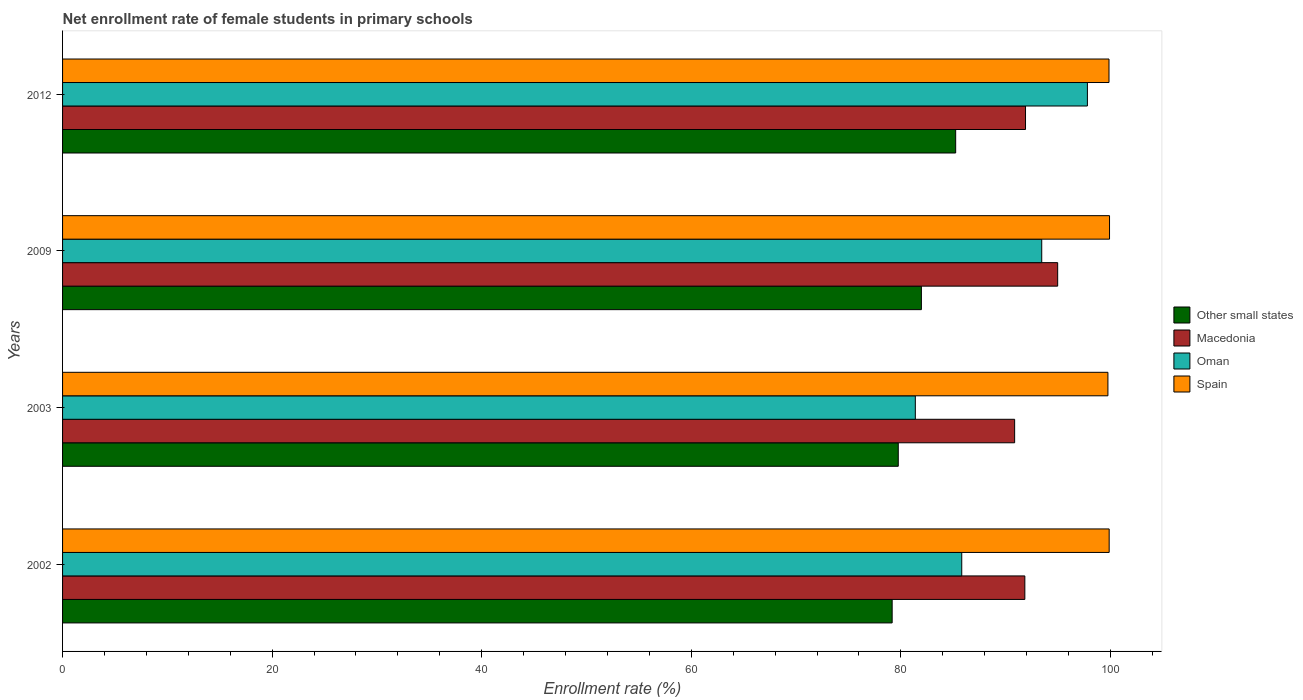How many different coloured bars are there?
Make the answer very short. 4. How many groups of bars are there?
Your answer should be compact. 4. Are the number of bars per tick equal to the number of legend labels?
Give a very brief answer. Yes. How many bars are there on the 3rd tick from the top?
Offer a terse response. 4. In how many cases, is the number of bars for a given year not equal to the number of legend labels?
Give a very brief answer. 0. What is the net enrollment rate of female students in primary schools in Other small states in 2012?
Your answer should be very brief. 85.23. Across all years, what is the maximum net enrollment rate of female students in primary schools in Spain?
Your answer should be compact. 99.91. Across all years, what is the minimum net enrollment rate of female students in primary schools in Macedonia?
Provide a succinct answer. 90.86. In which year was the net enrollment rate of female students in primary schools in Oman maximum?
Provide a short and direct response. 2012. In which year was the net enrollment rate of female students in primary schools in Spain minimum?
Your answer should be very brief. 2003. What is the total net enrollment rate of female students in primary schools in Macedonia in the graph?
Your answer should be compact. 369.55. What is the difference between the net enrollment rate of female students in primary schools in Macedonia in 2003 and that in 2012?
Ensure brevity in your answer.  -1.04. What is the difference between the net enrollment rate of female students in primary schools in Macedonia in 2003 and the net enrollment rate of female students in primary schools in Oman in 2012?
Ensure brevity in your answer.  -6.94. What is the average net enrollment rate of female students in primary schools in Macedonia per year?
Give a very brief answer. 92.39. In the year 2003, what is the difference between the net enrollment rate of female students in primary schools in Macedonia and net enrollment rate of female students in primary schools in Other small states?
Your answer should be compact. 11.11. What is the ratio of the net enrollment rate of female students in primary schools in Macedonia in 2009 to that in 2012?
Make the answer very short. 1.03. Is the net enrollment rate of female students in primary schools in Macedonia in 2002 less than that in 2003?
Your answer should be compact. No. What is the difference between the highest and the second highest net enrollment rate of female students in primary schools in Oman?
Offer a very short reply. 4.36. What is the difference between the highest and the lowest net enrollment rate of female students in primary schools in Spain?
Ensure brevity in your answer.  0.15. Is the sum of the net enrollment rate of female students in primary schools in Oman in 2003 and 2012 greater than the maximum net enrollment rate of female students in primary schools in Other small states across all years?
Provide a short and direct response. Yes. What does the 1st bar from the top in 2009 represents?
Keep it short and to the point. Spain. What does the 1st bar from the bottom in 2009 represents?
Offer a terse response. Other small states. Is it the case that in every year, the sum of the net enrollment rate of female students in primary schools in Spain and net enrollment rate of female students in primary schools in Oman is greater than the net enrollment rate of female students in primary schools in Other small states?
Your answer should be compact. Yes. How many bars are there?
Make the answer very short. 16. Are all the bars in the graph horizontal?
Make the answer very short. Yes. What is the difference between two consecutive major ticks on the X-axis?
Offer a very short reply. 20. Are the values on the major ticks of X-axis written in scientific E-notation?
Give a very brief answer. No. Does the graph contain any zero values?
Offer a terse response. No. Does the graph contain grids?
Provide a succinct answer. No. How are the legend labels stacked?
Make the answer very short. Vertical. What is the title of the graph?
Give a very brief answer. Net enrollment rate of female students in primary schools. What is the label or title of the X-axis?
Offer a terse response. Enrollment rate (%). What is the Enrollment rate (%) in Other small states in 2002?
Offer a terse response. 79.17. What is the Enrollment rate (%) of Macedonia in 2002?
Offer a very short reply. 91.83. What is the Enrollment rate (%) in Oman in 2002?
Provide a short and direct response. 85.81. What is the Enrollment rate (%) in Spain in 2002?
Provide a succinct answer. 99.88. What is the Enrollment rate (%) of Other small states in 2003?
Offer a terse response. 79.75. What is the Enrollment rate (%) in Macedonia in 2003?
Keep it short and to the point. 90.86. What is the Enrollment rate (%) in Oman in 2003?
Ensure brevity in your answer.  81.38. What is the Enrollment rate (%) of Spain in 2003?
Give a very brief answer. 99.76. What is the Enrollment rate (%) of Other small states in 2009?
Keep it short and to the point. 81.96. What is the Enrollment rate (%) in Macedonia in 2009?
Your response must be concise. 94.97. What is the Enrollment rate (%) of Oman in 2009?
Offer a very short reply. 93.44. What is the Enrollment rate (%) of Spain in 2009?
Your answer should be compact. 99.91. What is the Enrollment rate (%) of Other small states in 2012?
Keep it short and to the point. 85.23. What is the Enrollment rate (%) in Macedonia in 2012?
Offer a very short reply. 91.9. What is the Enrollment rate (%) in Oman in 2012?
Give a very brief answer. 97.8. What is the Enrollment rate (%) of Spain in 2012?
Make the answer very short. 99.86. Across all years, what is the maximum Enrollment rate (%) in Other small states?
Provide a succinct answer. 85.23. Across all years, what is the maximum Enrollment rate (%) of Macedonia?
Keep it short and to the point. 94.97. Across all years, what is the maximum Enrollment rate (%) in Oman?
Ensure brevity in your answer.  97.8. Across all years, what is the maximum Enrollment rate (%) of Spain?
Ensure brevity in your answer.  99.91. Across all years, what is the minimum Enrollment rate (%) in Other small states?
Ensure brevity in your answer.  79.17. Across all years, what is the minimum Enrollment rate (%) of Macedonia?
Make the answer very short. 90.86. Across all years, what is the minimum Enrollment rate (%) of Oman?
Ensure brevity in your answer.  81.38. Across all years, what is the minimum Enrollment rate (%) in Spain?
Your answer should be very brief. 99.76. What is the total Enrollment rate (%) in Other small states in the graph?
Offer a terse response. 326.11. What is the total Enrollment rate (%) in Macedonia in the graph?
Your response must be concise. 369.55. What is the total Enrollment rate (%) of Oman in the graph?
Keep it short and to the point. 358.44. What is the total Enrollment rate (%) of Spain in the graph?
Provide a short and direct response. 399.42. What is the difference between the Enrollment rate (%) in Other small states in 2002 and that in 2003?
Provide a succinct answer. -0.58. What is the difference between the Enrollment rate (%) of Macedonia in 2002 and that in 2003?
Provide a succinct answer. 0.97. What is the difference between the Enrollment rate (%) of Oman in 2002 and that in 2003?
Keep it short and to the point. 4.43. What is the difference between the Enrollment rate (%) of Spain in 2002 and that in 2003?
Your answer should be compact. 0.12. What is the difference between the Enrollment rate (%) of Other small states in 2002 and that in 2009?
Your answer should be very brief. -2.79. What is the difference between the Enrollment rate (%) in Macedonia in 2002 and that in 2009?
Ensure brevity in your answer.  -3.13. What is the difference between the Enrollment rate (%) in Oman in 2002 and that in 2009?
Make the answer very short. -7.63. What is the difference between the Enrollment rate (%) of Spain in 2002 and that in 2009?
Make the answer very short. -0.03. What is the difference between the Enrollment rate (%) of Other small states in 2002 and that in 2012?
Give a very brief answer. -6.06. What is the difference between the Enrollment rate (%) of Macedonia in 2002 and that in 2012?
Make the answer very short. -0.06. What is the difference between the Enrollment rate (%) of Oman in 2002 and that in 2012?
Make the answer very short. -11.99. What is the difference between the Enrollment rate (%) of Spain in 2002 and that in 2012?
Your answer should be very brief. 0.02. What is the difference between the Enrollment rate (%) of Other small states in 2003 and that in 2009?
Provide a succinct answer. -2.21. What is the difference between the Enrollment rate (%) in Macedonia in 2003 and that in 2009?
Your answer should be compact. -4.11. What is the difference between the Enrollment rate (%) of Oman in 2003 and that in 2009?
Provide a succinct answer. -12.06. What is the difference between the Enrollment rate (%) in Spain in 2003 and that in 2009?
Offer a terse response. -0.15. What is the difference between the Enrollment rate (%) in Other small states in 2003 and that in 2012?
Offer a terse response. -5.48. What is the difference between the Enrollment rate (%) of Macedonia in 2003 and that in 2012?
Give a very brief answer. -1.04. What is the difference between the Enrollment rate (%) of Oman in 2003 and that in 2012?
Your answer should be very brief. -16.42. What is the difference between the Enrollment rate (%) in Spain in 2003 and that in 2012?
Give a very brief answer. -0.1. What is the difference between the Enrollment rate (%) in Other small states in 2009 and that in 2012?
Provide a short and direct response. -3.27. What is the difference between the Enrollment rate (%) in Macedonia in 2009 and that in 2012?
Offer a terse response. 3.07. What is the difference between the Enrollment rate (%) of Oman in 2009 and that in 2012?
Ensure brevity in your answer.  -4.36. What is the difference between the Enrollment rate (%) in Spain in 2009 and that in 2012?
Offer a very short reply. 0.05. What is the difference between the Enrollment rate (%) in Other small states in 2002 and the Enrollment rate (%) in Macedonia in 2003?
Provide a short and direct response. -11.69. What is the difference between the Enrollment rate (%) of Other small states in 2002 and the Enrollment rate (%) of Oman in 2003?
Offer a terse response. -2.21. What is the difference between the Enrollment rate (%) of Other small states in 2002 and the Enrollment rate (%) of Spain in 2003?
Give a very brief answer. -20.59. What is the difference between the Enrollment rate (%) of Macedonia in 2002 and the Enrollment rate (%) of Oman in 2003?
Give a very brief answer. 10.45. What is the difference between the Enrollment rate (%) in Macedonia in 2002 and the Enrollment rate (%) in Spain in 2003?
Offer a terse response. -7.93. What is the difference between the Enrollment rate (%) of Oman in 2002 and the Enrollment rate (%) of Spain in 2003?
Keep it short and to the point. -13.95. What is the difference between the Enrollment rate (%) of Other small states in 2002 and the Enrollment rate (%) of Macedonia in 2009?
Ensure brevity in your answer.  -15.8. What is the difference between the Enrollment rate (%) of Other small states in 2002 and the Enrollment rate (%) of Oman in 2009?
Provide a short and direct response. -14.27. What is the difference between the Enrollment rate (%) of Other small states in 2002 and the Enrollment rate (%) of Spain in 2009?
Give a very brief answer. -20.74. What is the difference between the Enrollment rate (%) of Macedonia in 2002 and the Enrollment rate (%) of Oman in 2009?
Ensure brevity in your answer.  -1.61. What is the difference between the Enrollment rate (%) of Macedonia in 2002 and the Enrollment rate (%) of Spain in 2009?
Offer a very short reply. -8.08. What is the difference between the Enrollment rate (%) of Oman in 2002 and the Enrollment rate (%) of Spain in 2009?
Your answer should be very brief. -14.1. What is the difference between the Enrollment rate (%) in Other small states in 2002 and the Enrollment rate (%) in Macedonia in 2012?
Your answer should be compact. -12.73. What is the difference between the Enrollment rate (%) of Other small states in 2002 and the Enrollment rate (%) of Oman in 2012?
Make the answer very short. -18.63. What is the difference between the Enrollment rate (%) in Other small states in 2002 and the Enrollment rate (%) in Spain in 2012?
Offer a very short reply. -20.69. What is the difference between the Enrollment rate (%) of Macedonia in 2002 and the Enrollment rate (%) of Oman in 2012?
Ensure brevity in your answer.  -5.97. What is the difference between the Enrollment rate (%) in Macedonia in 2002 and the Enrollment rate (%) in Spain in 2012?
Your answer should be very brief. -8.03. What is the difference between the Enrollment rate (%) in Oman in 2002 and the Enrollment rate (%) in Spain in 2012?
Give a very brief answer. -14.05. What is the difference between the Enrollment rate (%) in Other small states in 2003 and the Enrollment rate (%) in Macedonia in 2009?
Your answer should be compact. -15.21. What is the difference between the Enrollment rate (%) of Other small states in 2003 and the Enrollment rate (%) of Oman in 2009?
Give a very brief answer. -13.69. What is the difference between the Enrollment rate (%) in Other small states in 2003 and the Enrollment rate (%) in Spain in 2009?
Provide a succinct answer. -20.16. What is the difference between the Enrollment rate (%) in Macedonia in 2003 and the Enrollment rate (%) in Oman in 2009?
Ensure brevity in your answer.  -2.59. What is the difference between the Enrollment rate (%) in Macedonia in 2003 and the Enrollment rate (%) in Spain in 2009?
Provide a short and direct response. -9.06. What is the difference between the Enrollment rate (%) of Oman in 2003 and the Enrollment rate (%) of Spain in 2009?
Provide a short and direct response. -18.53. What is the difference between the Enrollment rate (%) of Other small states in 2003 and the Enrollment rate (%) of Macedonia in 2012?
Keep it short and to the point. -12.14. What is the difference between the Enrollment rate (%) in Other small states in 2003 and the Enrollment rate (%) in Oman in 2012?
Offer a very short reply. -18.05. What is the difference between the Enrollment rate (%) in Other small states in 2003 and the Enrollment rate (%) in Spain in 2012?
Ensure brevity in your answer.  -20.11. What is the difference between the Enrollment rate (%) of Macedonia in 2003 and the Enrollment rate (%) of Oman in 2012?
Your answer should be very brief. -6.94. What is the difference between the Enrollment rate (%) in Macedonia in 2003 and the Enrollment rate (%) in Spain in 2012?
Provide a succinct answer. -9. What is the difference between the Enrollment rate (%) in Oman in 2003 and the Enrollment rate (%) in Spain in 2012?
Offer a very short reply. -18.48. What is the difference between the Enrollment rate (%) of Other small states in 2009 and the Enrollment rate (%) of Macedonia in 2012?
Offer a terse response. -9.94. What is the difference between the Enrollment rate (%) of Other small states in 2009 and the Enrollment rate (%) of Oman in 2012?
Offer a very short reply. -15.84. What is the difference between the Enrollment rate (%) in Other small states in 2009 and the Enrollment rate (%) in Spain in 2012?
Make the answer very short. -17.9. What is the difference between the Enrollment rate (%) of Macedonia in 2009 and the Enrollment rate (%) of Oman in 2012?
Offer a very short reply. -2.84. What is the difference between the Enrollment rate (%) in Macedonia in 2009 and the Enrollment rate (%) in Spain in 2012?
Offer a very short reply. -4.9. What is the difference between the Enrollment rate (%) of Oman in 2009 and the Enrollment rate (%) of Spain in 2012?
Give a very brief answer. -6.42. What is the average Enrollment rate (%) in Other small states per year?
Provide a succinct answer. 81.53. What is the average Enrollment rate (%) in Macedonia per year?
Make the answer very short. 92.39. What is the average Enrollment rate (%) of Oman per year?
Provide a short and direct response. 89.61. What is the average Enrollment rate (%) in Spain per year?
Ensure brevity in your answer.  99.85. In the year 2002, what is the difference between the Enrollment rate (%) in Other small states and Enrollment rate (%) in Macedonia?
Provide a succinct answer. -12.66. In the year 2002, what is the difference between the Enrollment rate (%) in Other small states and Enrollment rate (%) in Oman?
Ensure brevity in your answer.  -6.64. In the year 2002, what is the difference between the Enrollment rate (%) in Other small states and Enrollment rate (%) in Spain?
Your answer should be very brief. -20.71. In the year 2002, what is the difference between the Enrollment rate (%) of Macedonia and Enrollment rate (%) of Oman?
Your answer should be compact. 6.02. In the year 2002, what is the difference between the Enrollment rate (%) in Macedonia and Enrollment rate (%) in Spain?
Provide a succinct answer. -8.05. In the year 2002, what is the difference between the Enrollment rate (%) of Oman and Enrollment rate (%) of Spain?
Make the answer very short. -14.07. In the year 2003, what is the difference between the Enrollment rate (%) of Other small states and Enrollment rate (%) of Macedonia?
Ensure brevity in your answer.  -11.11. In the year 2003, what is the difference between the Enrollment rate (%) in Other small states and Enrollment rate (%) in Oman?
Make the answer very short. -1.63. In the year 2003, what is the difference between the Enrollment rate (%) of Other small states and Enrollment rate (%) of Spain?
Give a very brief answer. -20.01. In the year 2003, what is the difference between the Enrollment rate (%) of Macedonia and Enrollment rate (%) of Oman?
Your response must be concise. 9.48. In the year 2003, what is the difference between the Enrollment rate (%) of Macedonia and Enrollment rate (%) of Spain?
Make the answer very short. -8.9. In the year 2003, what is the difference between the Enrollment rate (%) in Oman and Enrollment rate (%) in Spain?
Your answer should be compact. -18.38. In the year 2009, what is the difference between the Enrollment rate (%) of Other small states and Enrollment rate (%) of Macedonia?
Make the answer very short. -13.01. In the year 2009, what is the difference between the Enrollment rate (%) in Other small states and Enrollment rate (%) in Oman?
Give a very brief answer. -11.48. In the year 2009, what is the difference between the Enrollment rate (%) in Other small states and Enrollment rate (%) in Spain?
Give a very brief answer. -17.95. In the year 2009, what is the difference between the Enrollment rate (%) in Macedonia and Enrollment rate (%) in Oman?
Provide a succinct answer. 1.52. In the year 2009, what is the difference between the Enrollment rate (%) in Macedonia and Enrollment rate (%) in Spain?
Offer a very short reply. -4.95. In the year 2009, what is the difference between the Enrollment rate (%) in Oman and Enrollment rate (%) in Spain?
Your answer should be very brief. -6.47. In the year 2012, what is the difference between the Enrollment rate (%) of Other small states and Enrollment rate (%) of Macedonia?
Make the answer very short. -6.67. In the year 2012, what is the difference between the Enrollment rate (%) in Other small states and Enrollment rate (%) in Oman?
Give a very brief answer. -12.57. In the year 2012, what is the difference between the Enrollment rate (%) of Other small states and Enrollment rate (%) of Spain?
Offer a terse response. -14.63. In the year 2012, what is the difference between the Enrollment rate (%) in Macedonia and Enrollment rate (%) in Oman?
Offer a terse response. -5.91. In the year 2012, what is the difference between the Enrollment rate (%) in Macedonia and Enrollment rate (%) in Spain?
Give a very brief answer. -7.97. In the year 2012, what is the difference between the Enrollment rate (%) in Oman and Enrollment rate (%) in Spain?
Your answer should be compact. -2.06. What is the ratio of the Enrollment rate (%) in Other small states in 2002 to that in 2003?
Your answer should be very brief. 0.99. What is the ratio of the Enrollment rate (%) of Macedonia in 2002 to that in 2003?
Make the answer very short. 1.01. What is the ratio of the Enrollment rate (%) in Oman in 2002 to that in 2003?
Your response must be concise. 1.05. What is the ratio of the Enrollment rate (%) in Oman in 2002 to that in 2009?
Keep it short and to the point. 0.92. What is the ratio of the Enrollment rate (%) in Other small states in 2002 to that in 2012?
Offer a terse response. 0.93. What is the ratio of the Enrollment rate (%) in Macedonia in 2002 to that in 2012?
Ensure brevity in your answer.  1. What is the ratio of the Enrollment rate (%) of Oman in 2002 to that in 2012?
Ensure brevity in your answer.  0.88. What is the ratio of the Enrollment rate (%) in Other small states in 2003 to that in 2009?
Your answer should be very brief. 0.97. What is the ratio of the Enrollment rate (%) in Macedonia in 2003 to that in 2009?
Make the answer very short. 0.96. What is the ratio of the Enrollment rate (%) in Oman in 2003 to that in 2009?
Provide a short and direct response. 0.87. What is the ratio of the Enrollment rate (%) in Spain in 2003 to that in 2009?
Make the answer very short. 1. What is the ratio of the Enrollment rate (%) of Other small states in 2003 to that in 2012?
Your answer should be very brief. 0.94. What is the ratio of the Enrollment rate (%) of Macedonia in 2003 to that in 2012?
Provide a short and direct response. 0.99. What is the ratio of the Enrollment rate (%) in Oman in 2003 to that in 2012?
Your response must be concise. 0.83. What is the ratio of the Enrollment rate (%) in Other small states in 2009 to that in 2012?
Your answer should be very brief. 0.96. What is the ratio of the Enrollment rate (%) in Macedonia in 2009 to that in 2012?
Ensure brevity in your answer.  1.03. What is the ratio of the Enrollment rate (%) of Oman in 2009 to that in 2012?
Ensure brevity in your answer.  0.96. What is the ratio of the Enrollment rate (%) in Spain in 2009 to that in 2012?
Your answer should be very brief. 1. What is the difference between the highest and the second highest Enrollment rate (%) in Other small states?
Your answer should be very brief. 3.27. What is the difference between the highest and the second highest Enrollment rate (%) of Macedonia?
Your answer should be very brief. 3.07. What is the difference between the highest and the second highest Enrollment rate (%) in Oman?
Provide a short and direct response. 4.36. What is the difference between the highest and the second highest Enrollment rate (%) of Spain?
Offer a terse response. 0.03. What is the difference between the highest and the lowest Enrollment rate (%) in Other small states?
Offer a terse response. 6.06. What is the difference between the highest and the lowest Enrollment rate (%) of Macedonia?
Give a very brief answer. 4.11. What is the difference between the highest and the lowest Enrollment rate (%) in Oman?
Ensure brevity in your answer.  16.42. What is the difference between the highest and the lowest Enrollment rate (%) in Spain?
Provide a short and direct response. 0.15. 